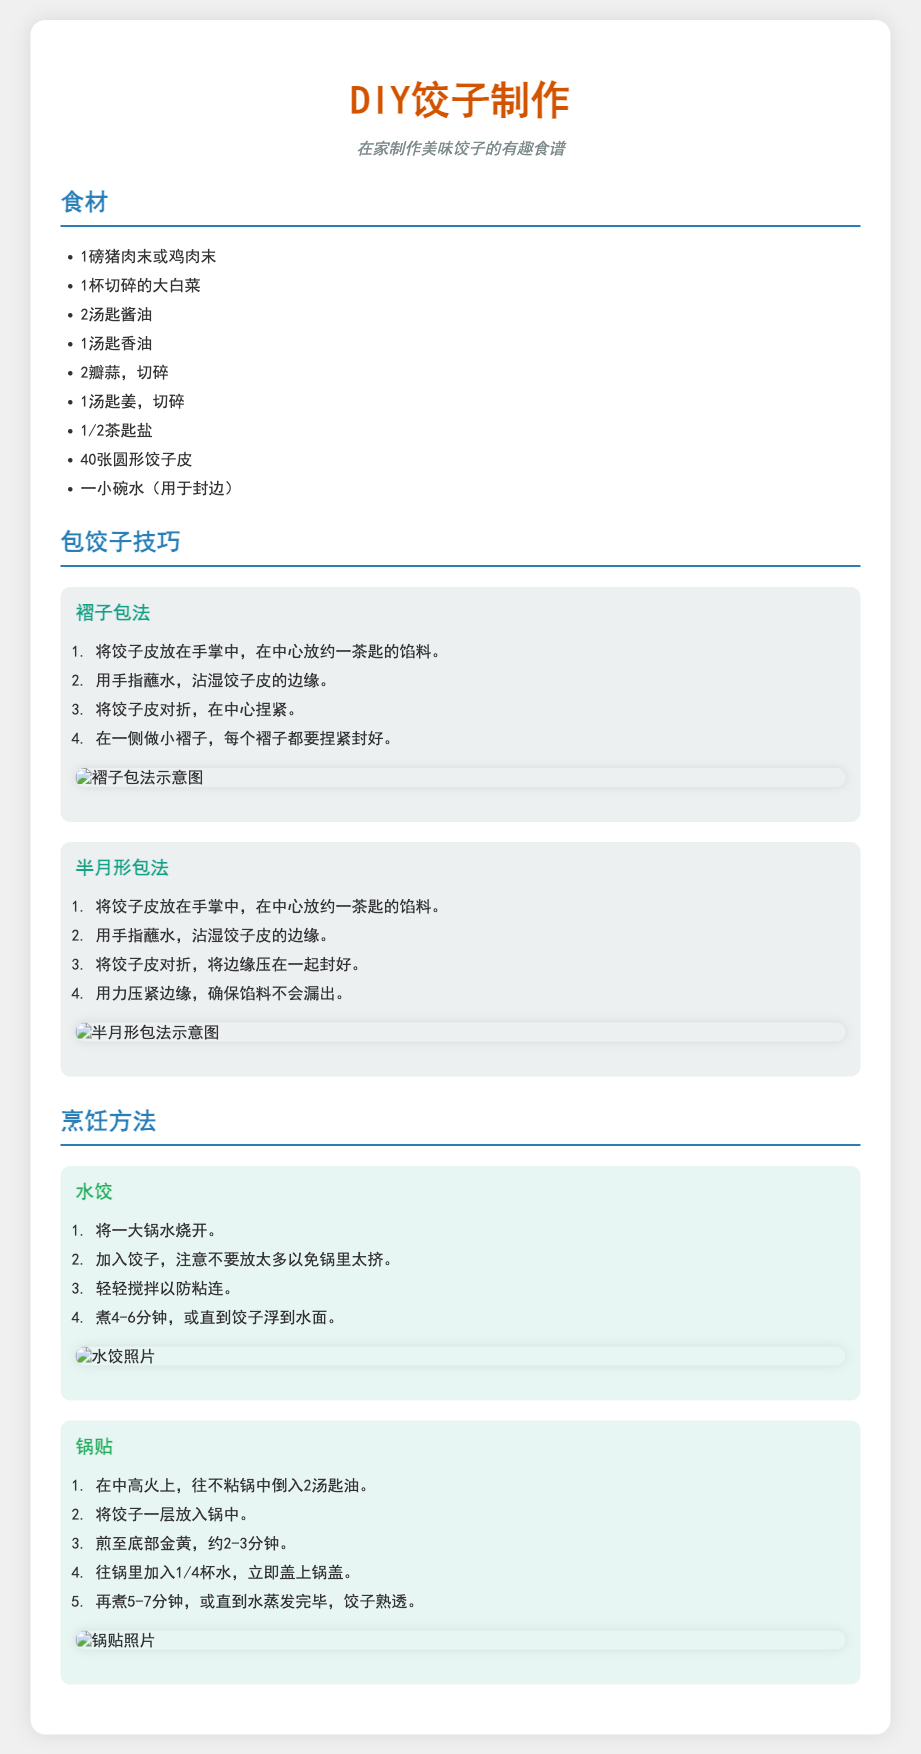什么是主要的食材之一？ 主要的食材是制作饺子的成分，列在“食材”部分。
Answer: 猪肉末或鸡肉末 包饺子有几种技巧？ 文档中提到有两种包饺子的技巧，分别是在“包饺子技巧”部分列出的。
Answer: 两种 水饺的烹饪时间是多少分钟？ 文档指出水饺需要煮4-6分钟，位于“烹饪方法”部分中的水饺描述里。
Answer: 4-6分钟 锅贴添加多少水来蒸熟？ 在锅贴的烹饪步骤中提到加入1/4杯水。
Answer: 1/4杯 饺子皮的数量是多少？ 食材列表中直接列出了饺子皮的数量。
Answer: 40张 煮饺子的锅中需要加多少水？ 文档提到“将一大锅水烧开”，说明需要一大锅水。
Answer: 一大锅水 参加包饺子技巧的褶子包法第一步是什么？ 褶子包法的第一步描述在“包饺子技巧”部分中可找到。
Answer: 放馅料 锅贴底部金黄需要煎多长时间？ 在锅贴的步骤中指出底部金黄需要煎2-3分钟。
Answer: 2-3分钟 用来封边的是什么？ 文档中提到用“一小碗水”来封边。
Answer: 一小碗水 